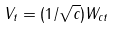Convert formula to latex. <formula><loc_0><loc_0><loc_500><loc_500>V _ { t } = ( 1 / \sqrt { c } ) W _ { c t }</formula> 